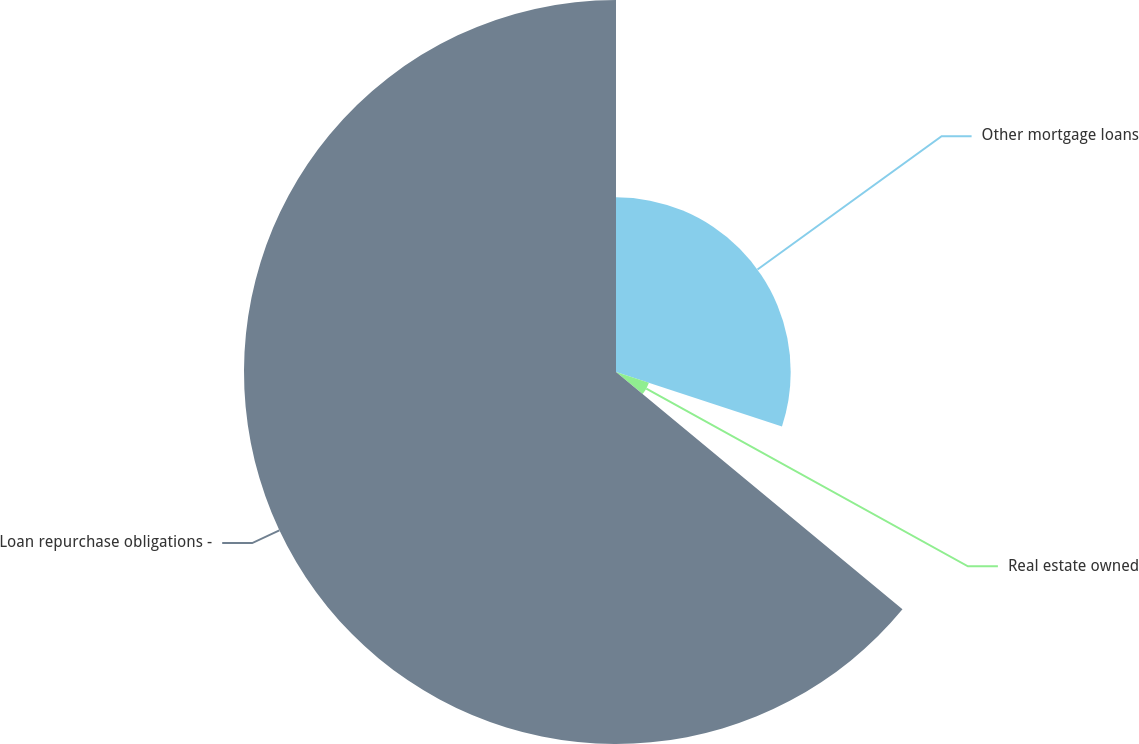Convert chart. <chart><loc_0><loc_0><loc_500><loc_500><pie_chart><fcel>Other mortgage loans<fcel>Real estate owned<fcel>Loan repurchase obligations -<nl><fcel>30.05%<fcel>5.96%<fcel>63.99%<nl></chart> 